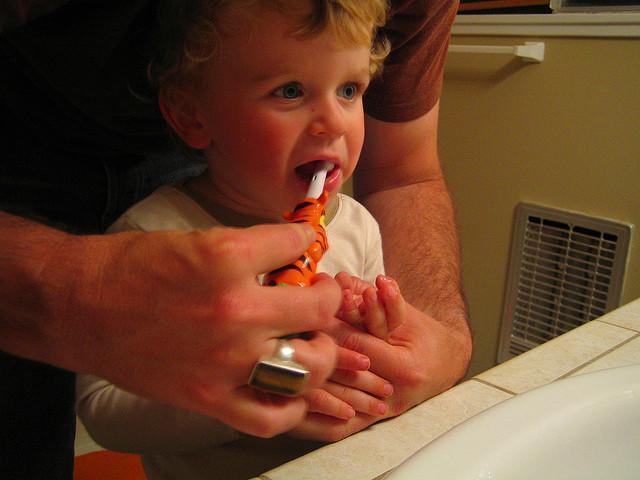How many people are in the photo?
Give a very brief answer. 2. How many people can be seen?
Give a very brief answer. 2. How many toothbrushes are in the photo?
Give a very brief answer. 1. How many of these elephants look like they are babies?
Give a very brief answer. 0. 